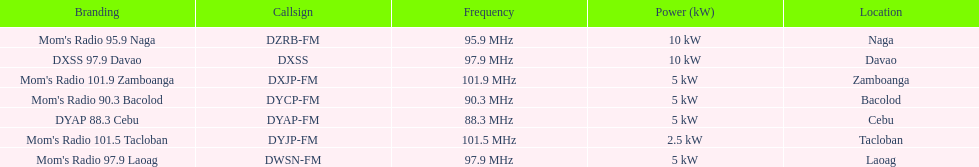How many times is the frequency greater than 95? 5. Give me the full table as a dictionary. {'header': ['Branding', 'Callsign', 'Frequency', 'Power (kW)', 'Location'], 'rows': [["Mom's Radio 95.9 Naga", 'DZRB-FM', '95.9\xa0MHz', '10\xa0kW', 'Naga'], ['DXSS 97.9 Davao', 'DXSS', '97.9\xa0MHz', '10\xa0kW', 'Davao'], ["Mom's Radio 101.9 Zamboanga", 'DXJP-FM', '101.9\xa0MHz', '5\xa0kW', 'Zamboanga'], ["Mom's Radio 90.3 Bacolod", 'DYCP-FM', '90.3\xa0MHz', '5\xa0kW', 'Bacolod'], ['DYAP 88.3 Cebu', 'DYAP-FM', '88.3\xa0MHz', '5\xa0kW', 'Cebu'], ["Mom's Radio 101.5 Tacloban", 'DYJP-FM', '101.5\xa0MHz', '2.5\xa0kW', 'Tacloban'], ["Mom's Radio 97.9 Laoag", 'DWSN-FM', '97.9\xa0MHz', '5\xa0kW', 'Laoag']]} 